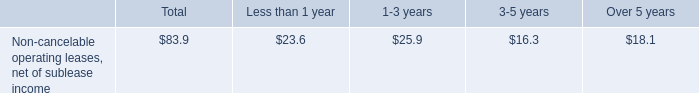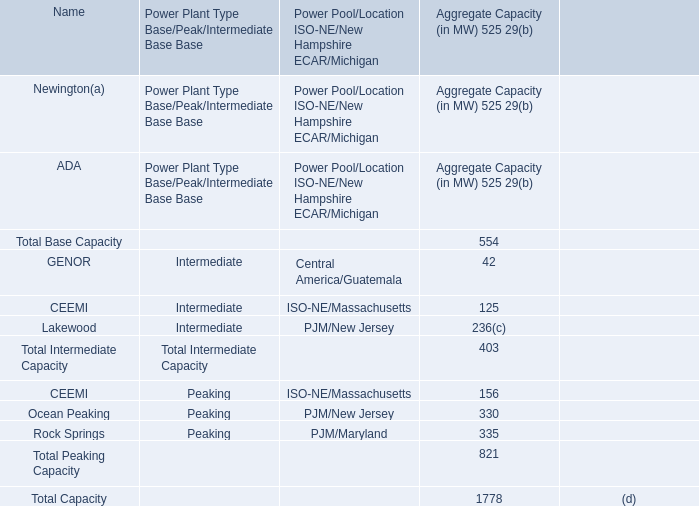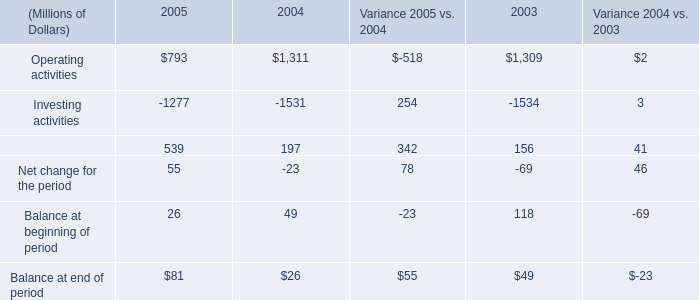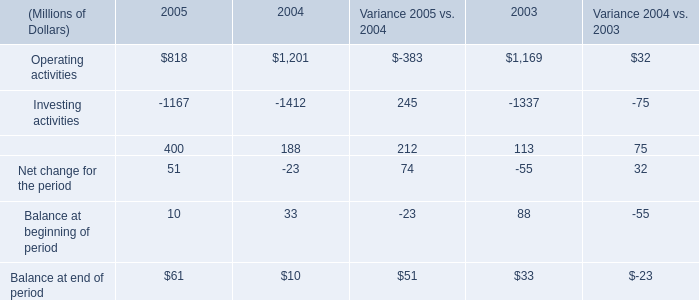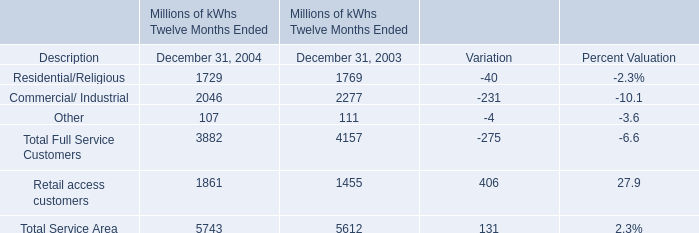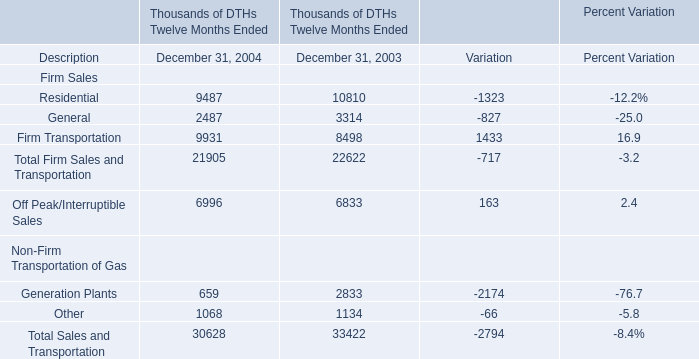If Firm Transportation develops with the same growth rate in 2004, what will it reach in 2005? 
Computations: (9931 * (1 + ((9931 - 8498) / 8498)))
Answer: 11605.6438. 